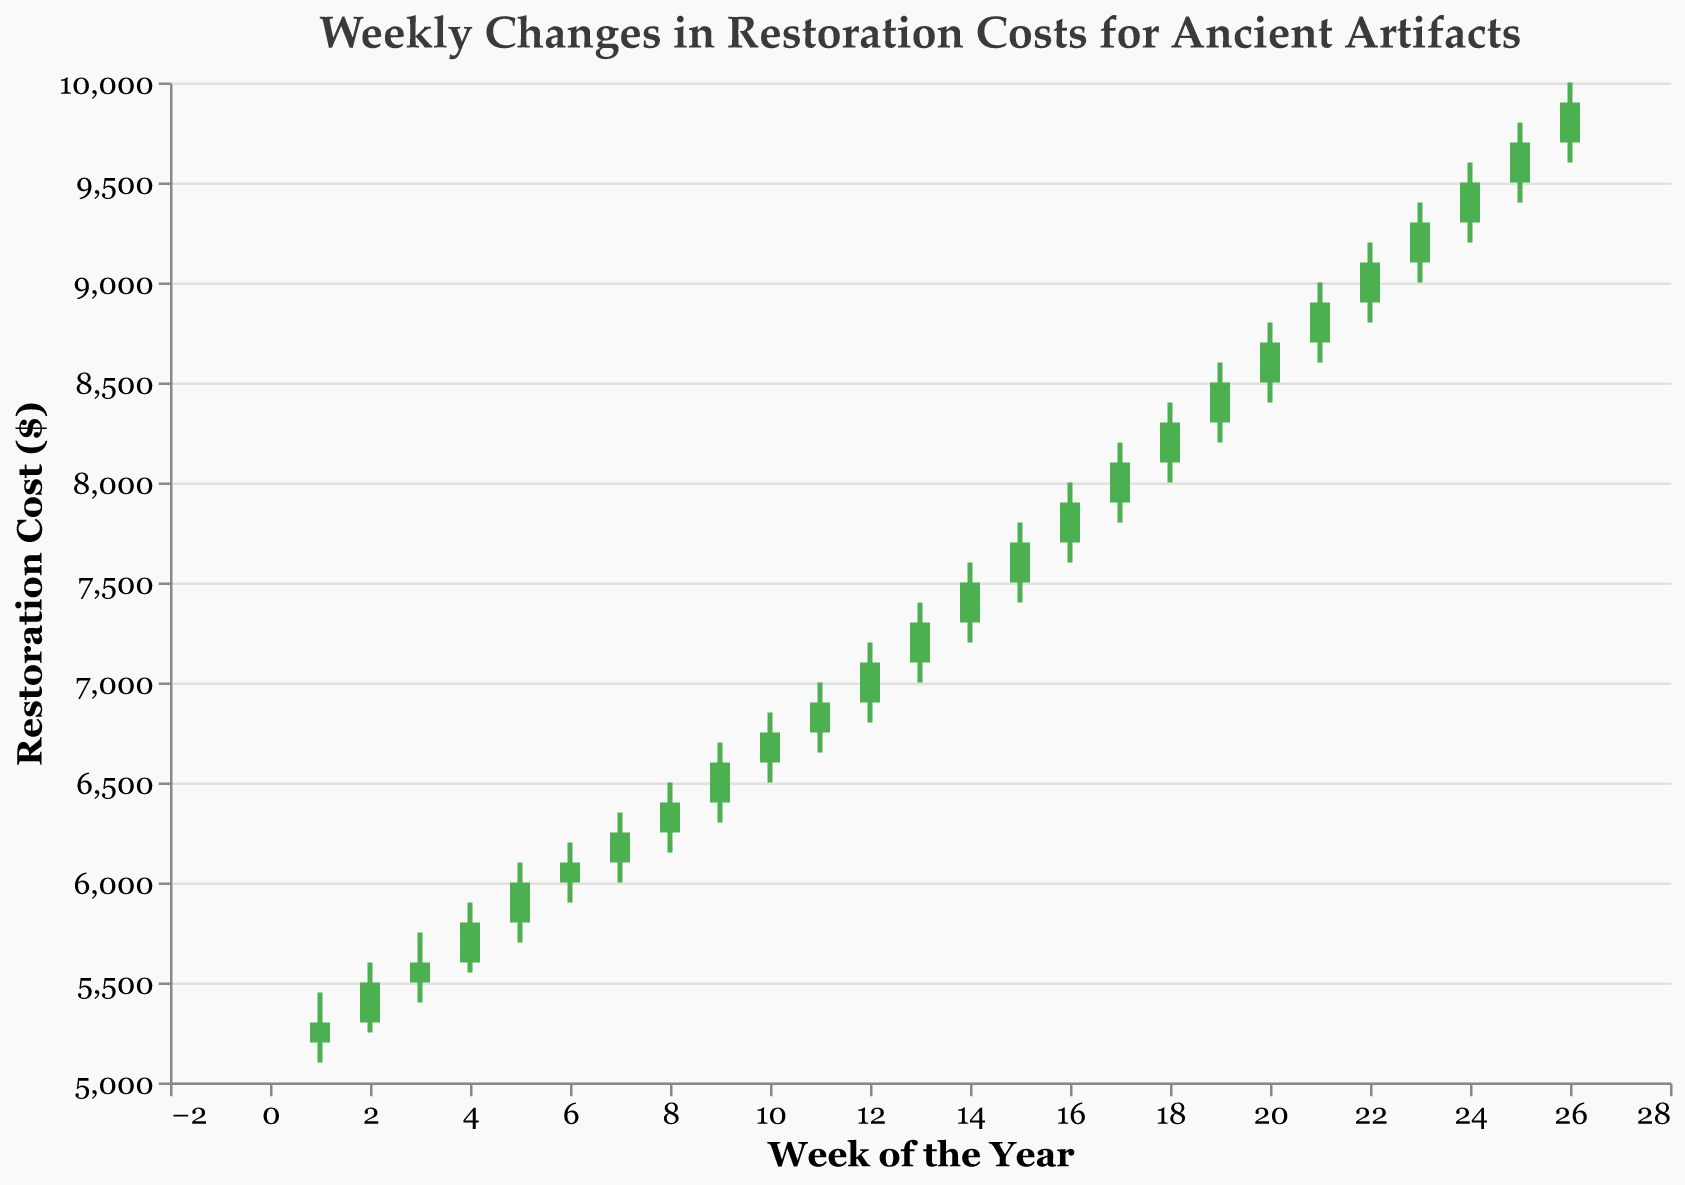What is the title of the chart? The title is at the top of the chart. It reads "Weekly Changes in Restoration Costs for Ancient Artifacts."
Answer: Weekly Changes in Restoration Costs for Ancient Artifacts Which color indicates that the restoration cost increased from the weekly opening to closing? The color indicating an increase is shown in the chart. Green bars represent weeks where the closing cost is higher than the opening cost.
Answer: Green During which week did the highest restoration cost occur? Look at the 'High' values marked on the chart. The highest 'High' value is 10,000, which occurs in week 26.
Answer: Week 26 What is the range of restoration costs in week 10? Locate week 10 in the chart and note the 'Low' and 'High' values. The low is 6500, and the high is 6850. The range is 6850 - 6500 = 350.
Answer: 350 How many weeks had a closing restoration cost of 9000 or more? Scan through the 'Close' values and count the weeks with a closing cost of 9000 or more. Weeks 21 to 26 all have closing costs of 9000 or more. There are 6 weeks in total.
Answer: 6 In which week did the lowest restoration cost occur? Check the 'Low' values across all weeks. The lowest 'Low' value is 5100 in week 1.
Answer: Week 1 What is the difference between the highest and lowest closing costs over the year? Find the highest and lowest 'Close' values in the chart. The highest is 9900 (week 26), and the lowest is 5300 (week 1). The difference is 9900 - 5300 = 4600.
Answer: 4600 Between which two consecutive weeks is the largest weekly increase in closing costs? Calculate the difference in 'Close' values for each consecutive week and find the maximum. From week 25 to week 26, the increase is 9900 - 9700 = 200.
Answer: Week 25 to Week 26 During which week did the color of the bar indicate a decline in restoration costs? Identify the weeks where the bar is red. The bar is red for week 11, indicating that the closing cost is lower than the opening cost.
Answer: Week 11 What is the average weekly opening cost from week 1 to week 13? Sum the 'Open' values from weeks 1 to 13 and divide by 13. The sum is (5200 + 5300 + 5500 + 5600 + 5800 + 6000 + 6100 + 6250 + 6400 + 6600 + 6750 + 6900 + 7100 = 80500). The average is 80500 / 13 ≈ 6192.31
Answer: 6192.31 